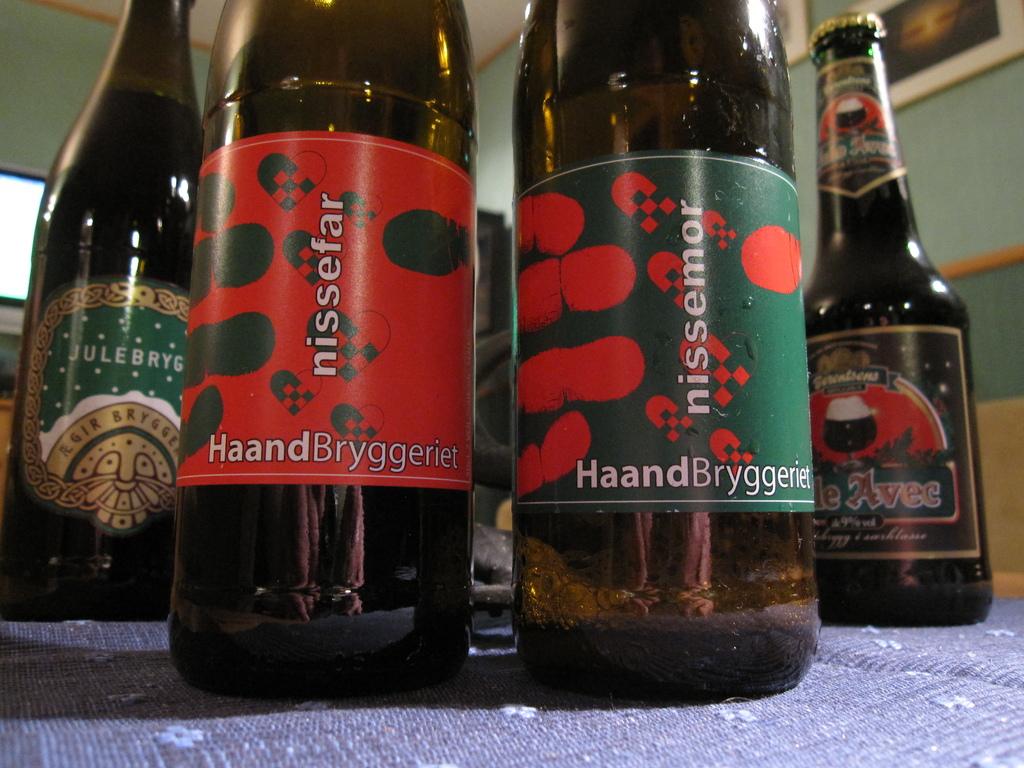What is in the bottles?
Keep it short and to the point. Nissefar. Does the bottle to the left's name start with jule?
Your answer should be very brief. Yes. 